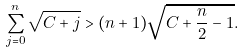<formula> <loc_0><loc_0><loc_500><loc_500>\sum _ { j = 0 } ^ { n } \sqrt { C + j } > ( n + 1 ) \sqrt { C + \frac { n } { 2 } - 1 } .</formula> 